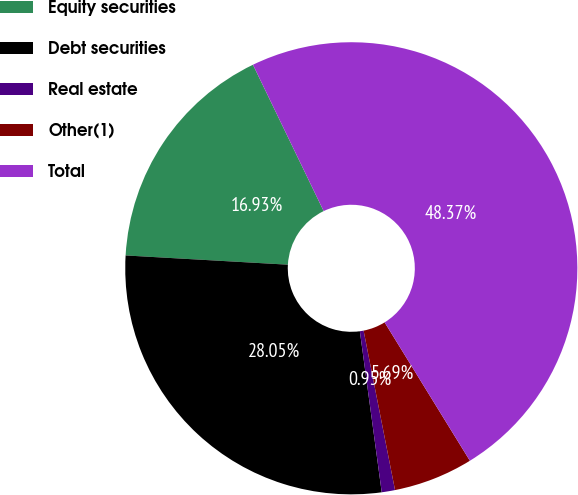Convert chart to OTSL. <chart><loc_0><loc_0><loc_500><loc_500><pie_chart><fcel>Equity securities<fcel>Debt securities<fcel>Real estate<fcel>Other(1)<fcel>Total<nl><fcel>16.93%<fcel>28.05%<fcel>0.95%<fcel>5.69%<fcel>48.37%<nl></chart> 